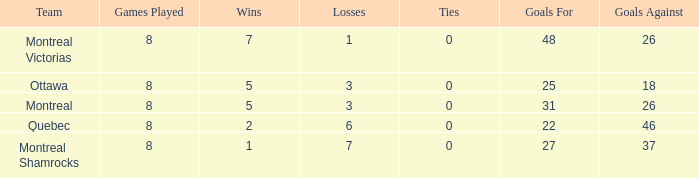How many losses did the team with 22 goals for andmore than 8 games played have? 0.0. 